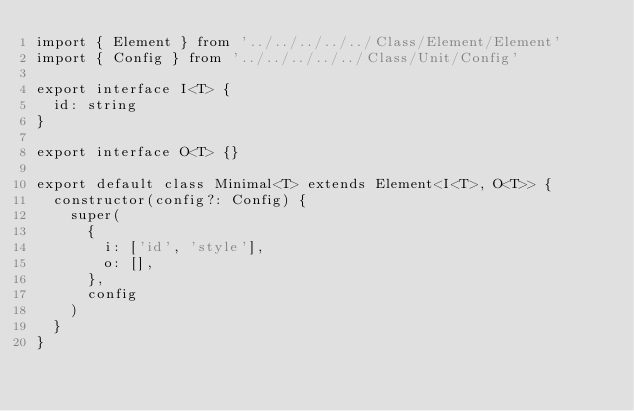Convert code to text. <code><loc_0><loc_0><loc_500><loc_500><_TypeScript_>import { Element } from '../../../../../Class/Element/Element'
import { Config } from '../../../../../Class/Unit/Config'

export interface I<T> {
  id: string
}

export interface O<T> {}

export default class Minimal<T> extends Element<I<T>, O<T>> {
  constructor(config?: Config) {
    super(
      {
        i: ['id', 'style'],
        o: [],
      },
      config
    )
  }
}
</code> 